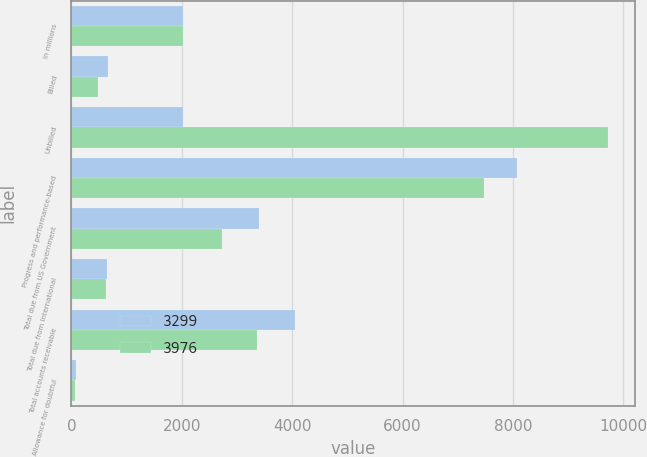<chart> <loc_0><loc_0><loc_500><loc_500><stacked_bar_chart><ecel><fcel>in millions<fcel>Billed<fcel>Unbilled<fcel>Progress and performance-based<fcel>Total due from US Government<fcel>Total due from International<fcel>Total accounts receivable<fcel>Allowance for doubtful<nl><fcel>3299<fcel>2017<fcel>656<fcel>2017<fcel>8068<fcel>3406<fcel>649<fcel>4055<fcel>79<nl><fcel>3976<fcel>2016<fcel>482<fcel>9730<fcel>7484<fcel>2728<fcel>634<fcel>3362<fcel>63<nl></chart> 